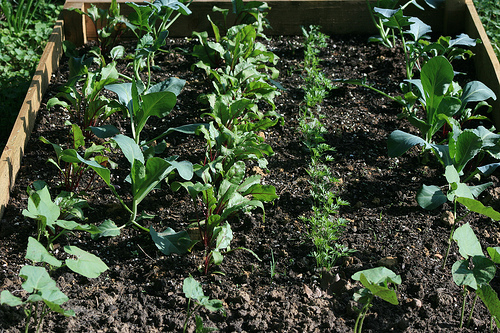<image>
Is there a plant in the box? Yes. The plant is contained within or inside the box, showing a containment relationship. 